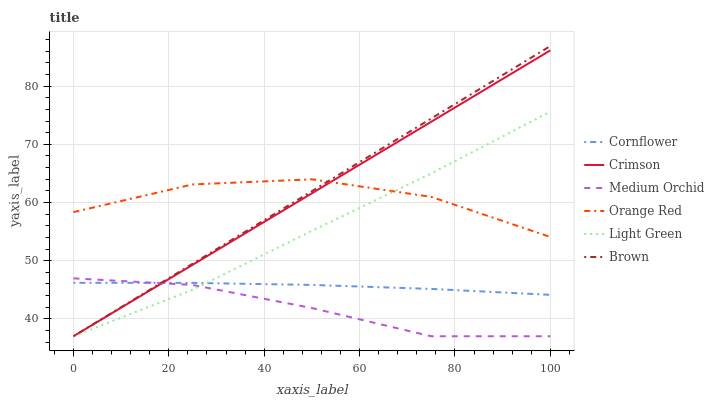Does Medium Orchid have the minimum area under the curve?
Answer yes or no. Yes. Does Brown have the maximum area under the curve?
Answer yes or no. Yes. Does Brown have the minimum area under the curve?
Answer yes or no. No. Does Medium Orchid have the maximum area under the curve?
Answer yes or no. No. Is Brown the smoothest?
Answer yes or no. Yes. Is Orange Red the roughest?
Answer yes or no. Yes. Is Medium Orchid the smoothest?
Answer yes or no. No. Is Medium Orchid the roughest?
Answer yes or no. No. Does Brown have the lowest value?
Answer yes or no. Yes. Does Orange Red have the lowest value?
Answer yes or no. No. Does Brown have the highest value?
Answer yes or no. Yes. Does Medium Orchid have the highest value?
Answer yes or no. No. Is Medium Orchid less than Orange Red?
Answer yes or no. Yes. Is Orange Red greater than Cornflower?
Answer yes or no. Yes. Does Light Green intersect Brown?
Answer yes or no. Yes. Is Light Green less than Brown?
Answer yes or no. No. Is Light Green greater than Brown?
Answer yes or no. No. Does Medium Orchid intersect Orange Red?
Answer yes or no. No. 